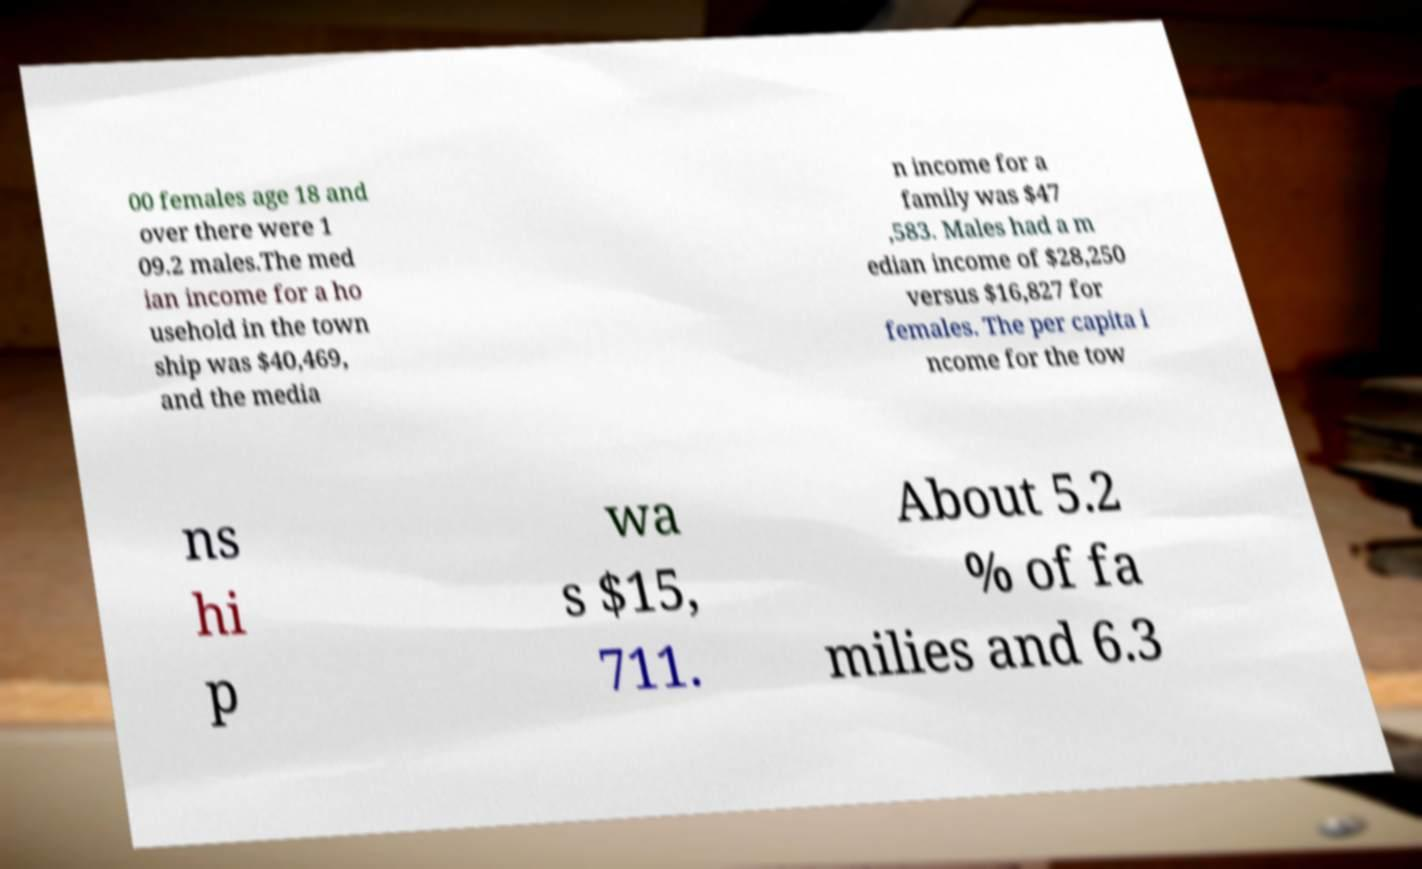For documentation purposes, I need the text within this image transcribed. Could you provide that? 00 females age 18 and over there were 1 09.2 males.The med ian income for a ho usehold in the town ship was $40,469, and the media n income for a family was $47 ,583. Males had a m edian income of $28,250 versus $16,827 for females. The per capita i ncome for the tow ns hi p wa s $15, 711. About 5.2 % of fa milies and 6.3 